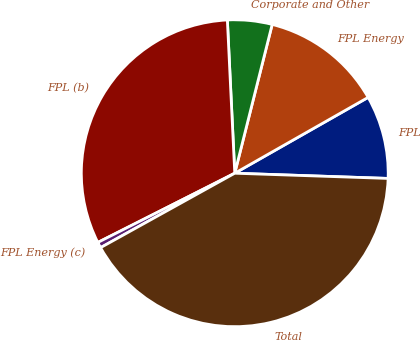Convert chart. <chart><loc_0><loc_0><loc_500><loc_500><pie_chart><fcel>FPL<fcel>FPL Energy<fcel>Corporate and Other<fcel>FPL (b)<fcel>FPL Energy (c)<fcel>Total<nl><fcel>8.77%<fcel>12.85%<fcel>4.69%<fcel>31.68%<fcel>0.61%<fcel>41.4%<nl></chart> 